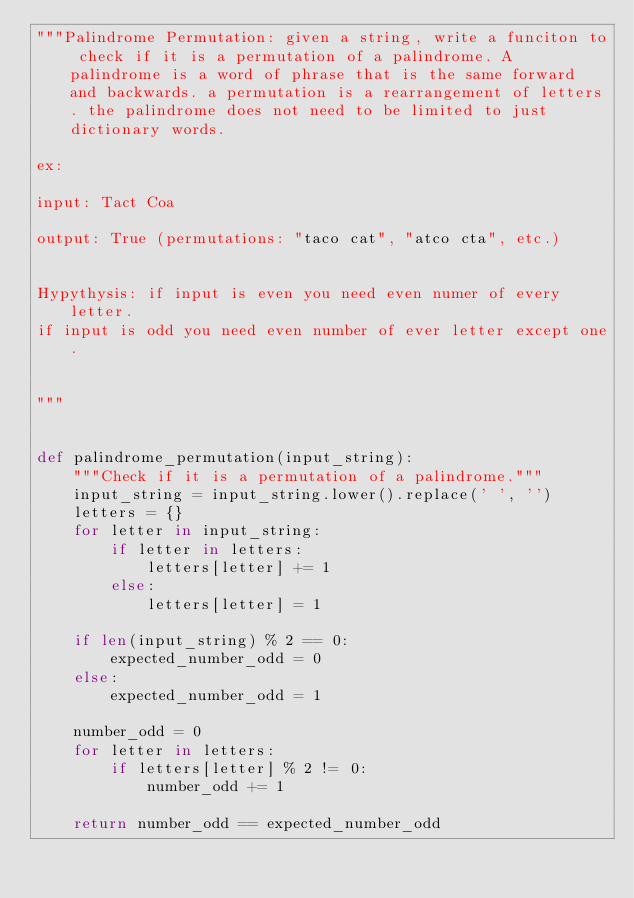<code> <loc_0><loc_0><loc_500><loc_500><_Python_>"""Palindrome Permutation: given a string, write a funciton to check if it is a permutation of a palindrome. A palindrome is a word of phrase that is the same forward and backwards. a permutation is a rearrangement of letters. the palindrome does not need to be limited to just dictionary words.

ex:

input: Tact Coa

output: True (permutations: "taco cat", "atco cta", etc.)


Hypythysis: if input is even you need even numer of every letter.
if input is odd you need even number of ever letter except one. 


"""


def palindrome_permutation(input_string):
    """Check if it is a permutation of a palindrome."""
    input_string = input_string.lower().replace(' ', '')
    letters = {}
    for letter in input_string:
        if letter in letters:
            letters[letter] += 1
        else:
            letters[letter] = 1

    if len(input_string) % 2 == 0:
        expected_number_odd = 0
    else:
        expected_number_odd = 1

    number_odd = 0
    for letter in letters:
        if letters[letter] % 2 != 0:
            number_odd += 1

    return number_odd == expected_number_odd
</code> 